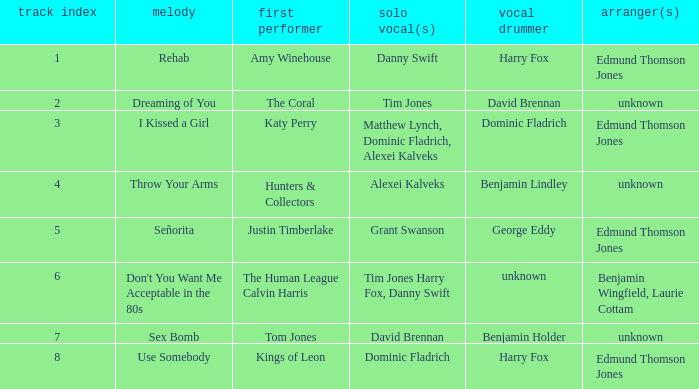Who is the artist where the vocal percussionist is Benjamin Holder? Tom Jones. Could you parse the entire table? {'header': ['track index', 'melody', 'first performer', 'solo vocal(s)', 'vocal drummer', 'arranger(s)'], 'rows': [['1', 'Rehab', 'Amy Winehouse', 'Danny Swift', 'Harry Fox', 'Edmund Thomson Jones'], ['2', 'Dreaming of You', 'The Coral', 'Tim Jones', 'David Brennan', 'unknown'], ['3', 'I Kissed a Girl', 'Katy Perry', 'Matthew Lynch, Dominic Fladrich, Alexei Kalveks', 'Dominic Fladrich', 'Edmund Thomson Jones'], ['4', 'Throw Your Arms', 'Hunters & Collectors', 'Alexei Kalveks', 'Benjamin Lindley', 'unknown'], ['5', 'Señorita', 'Justin Timberlake', 'Grant Swanson', 'George Eddy', 'Edmund Thomson Jones'], ['6', "Don't You Want Me Acceptable in the 80s", 'The Human League Calvin Harris', 'Tim Jones Harry Fox, Danny Swift', 'unknown', 'Benjamin Wingfield, Laurie Cottam'], ['7', 'Sex Bomb', 'Tom Jones', 'David Brennan', 'Benjamin Holder', 'unknown'], ['8', 'Use Somebody', 'Kings of Leon', 'Dominic Fladrich', 'Harry Fox', 'Edmund Thomson Jones']]} 